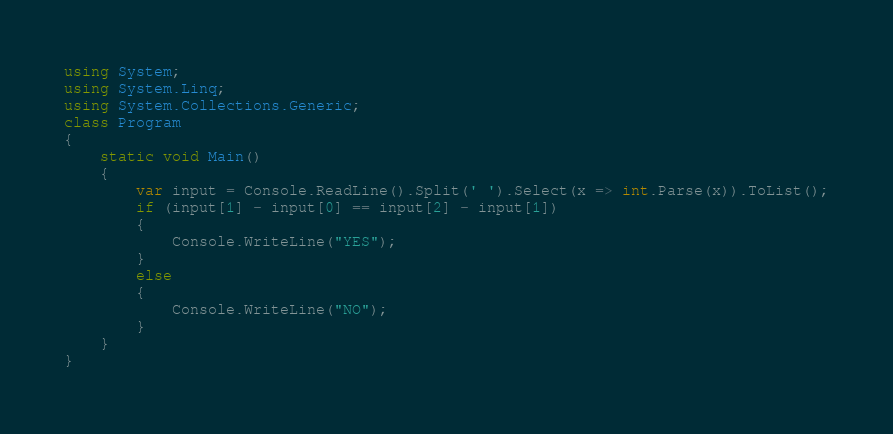Convert code to text. <code><loc_0><loc_0><loc_500><loc_500><_C#_>using System;
using System.Linq;
using System.Collections.Generic;
class Program
{
    static void Main()
    {
        var input = Console.ReadLine().Split(' ').Select(x => int.Parse(x)).ToList();
        if (input[1] - input[0] == input[2] - input[1])
        {
            Console.WriteLine("YES");
        }
        else
        {
            Console.WriteLine("NO");
        }
    }
}</code> 